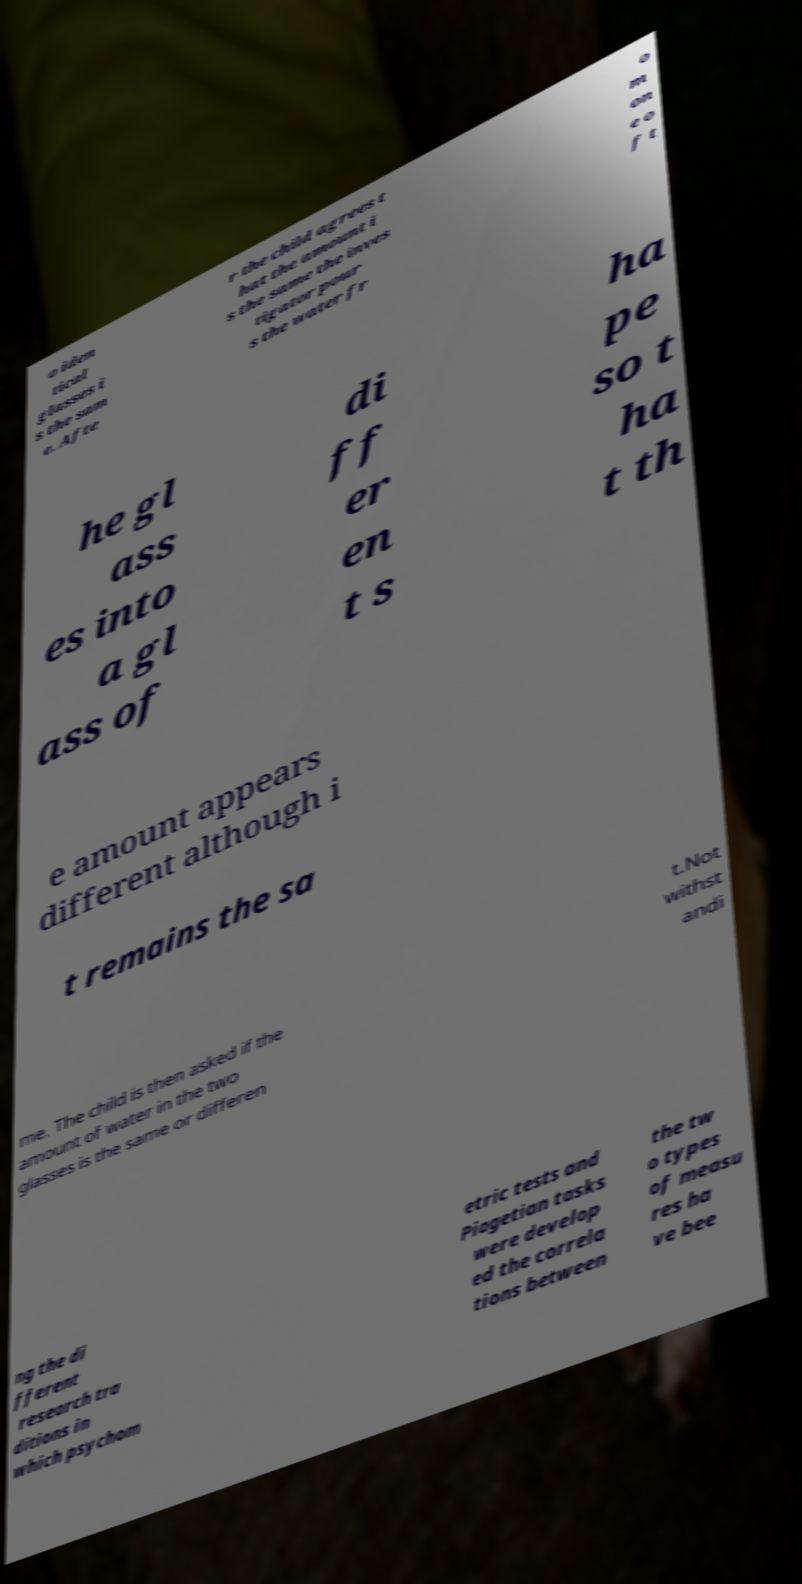What messages or text are displayed in this image? I need them in a readable, typed format. o iden tical glasses i s the sam e. Afte r the child agrees t hat the amount i s the same the inves tigator pour s the water fr o m on e o f t he gl ass es into a gl ass of di ff er en t s ha pe so t ha t th e amount appears different although i t remains the sa me. The child is then asked if the amount of water in the two glasses is the same or differen t.Not withst andi ng the di fferent research tra ditions in which psychom etric tests and Piagetian tasks were develop ed the correla tions between the tw o types of measu res ha ve bee 